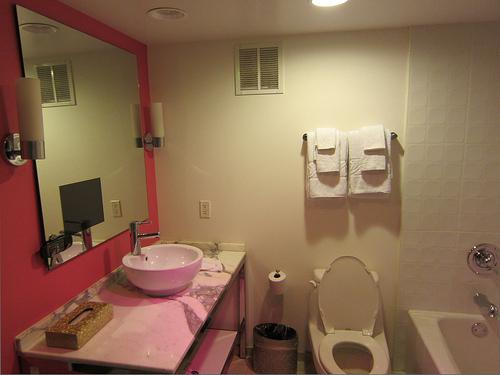Question: why is the room bright?
Choices:
A. A light is on.
B. The sun is shining.
C. The camera's flash.
D. The lights are off.
Answer with the letter. Answer: A Question: where was this picture taken?
Choices:
A. Kitchen.
B. Backyard.
C. Living room.
D. The bathroom.
Answer with the letter. Answer: D Question: what color is the toilet?
Choices:
A. Black.
B. White.
C. Red.
D. Brown.
Answer with the letter. Answer: B Question: where is there a trash can?
Choices:
A. Outside.
B. In the kitchen.
C. In the office.
D. Next to the toilet.
Answer with the letter. Answer: D Question: where is there a tissue box?
Choices:
A. In the bathroom.
B. The counter.
C. Near the bed.
D. On the table.
Answer with the letter. Answer: B Question: what is hanging on the towel rack?
Choices:
A. Towels.
B. Shirt.
C. Pants.
D. Wash cloth.
Answer with the letter. Answer: A Question: what color is the wall above the sink?
Choices:
A. Black.
B. Red.
C. White.
D. Brown.
Answer with the letter. Answer: B 